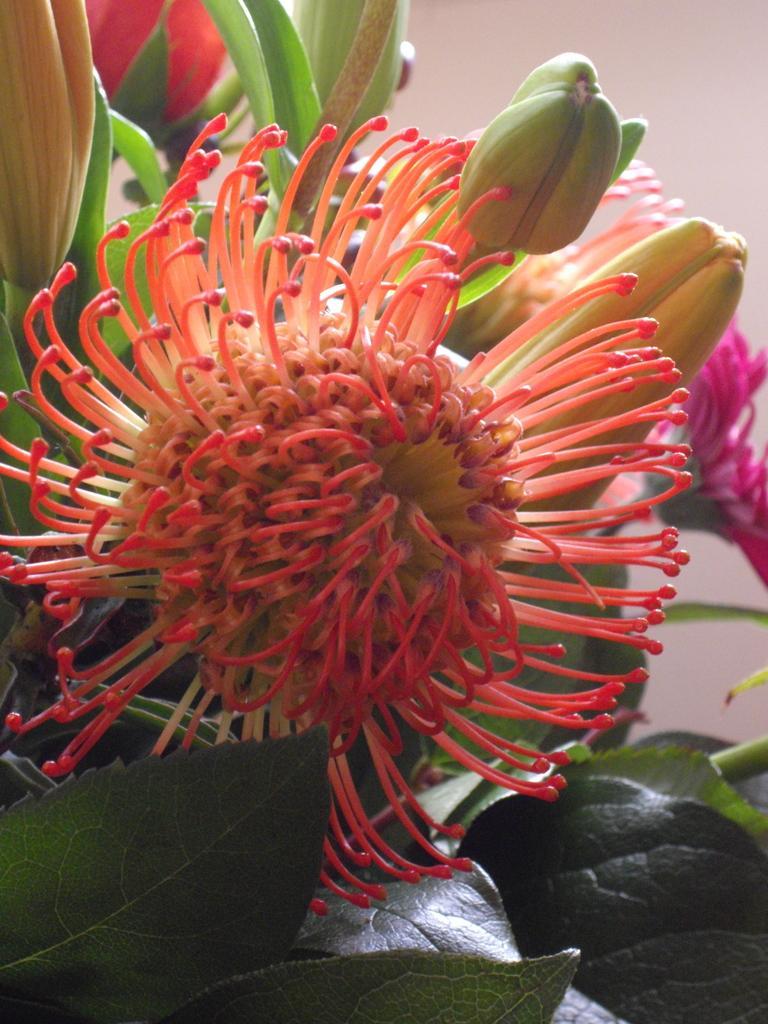Please provide a concise description of this image. In the image we can see some flowers and plants. 